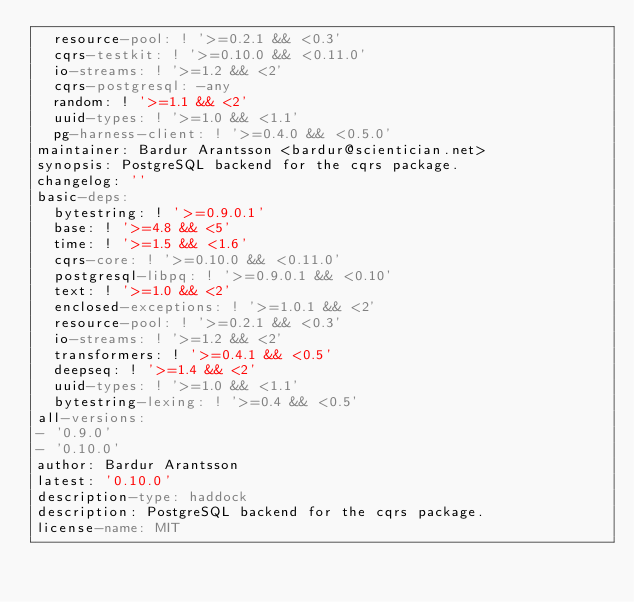Convert code to text. <code><loc_0><loc_0><loc_500><loc_500><_YAML_>  resource-pool: ! '>=0.2.1 && <0.3'
  cqrs-testkit: ! '>=0.10.0 && <0.11.0'
  io-streams: ! '>=1.2 && <2'
  cqrs-postgresql: -any
  random: ! '>=1.1 && <2'
  uuid-types: ! '>=1.0 && <1.1'
  pg-harness-client: ! '>=0.4.0 && <0.5.0'
maintainer: Bardur Arantsson <bardur@scientician.net>
synopsis: PostgreSQL backend for the cqrs package.
changelog: ''
basic-deps:
  bytestring: ! '>=0.9.0.1'
  base: ! '>=4.8 && <5'
  time: ! '>=1.5 && <1.6'
  cqrs-core: ! '>=0.10.0 && <0.11.0'
  postgresql-libpq: ! '>=0.9.0.1 && <0.10'
  text: ! '>=1.0 && <2'
  enclosed-exceptions: ! '>=1.0.1 && <2'
  resource-pool: ! '>=0.2.1 && <0.3'
  io-streams: ! '>=1.2 && <2'
  transformers: ! '>=0.4.1 && <0.5'
  deepseq: ! '>=1.4 && <2'
  uuid-types: ! '>=1.0 && <1.1'
  bytestring-lexing: ! '>=0.4 && <0.5'
all-versions:
- '0.9.0'
- '0.10.0'
author: Bardur Arantsson
latest: '0.10.0'
description-type: haddock
description: PostgreSQL backend for the cqrs package.
license-name: MIT
</code> 